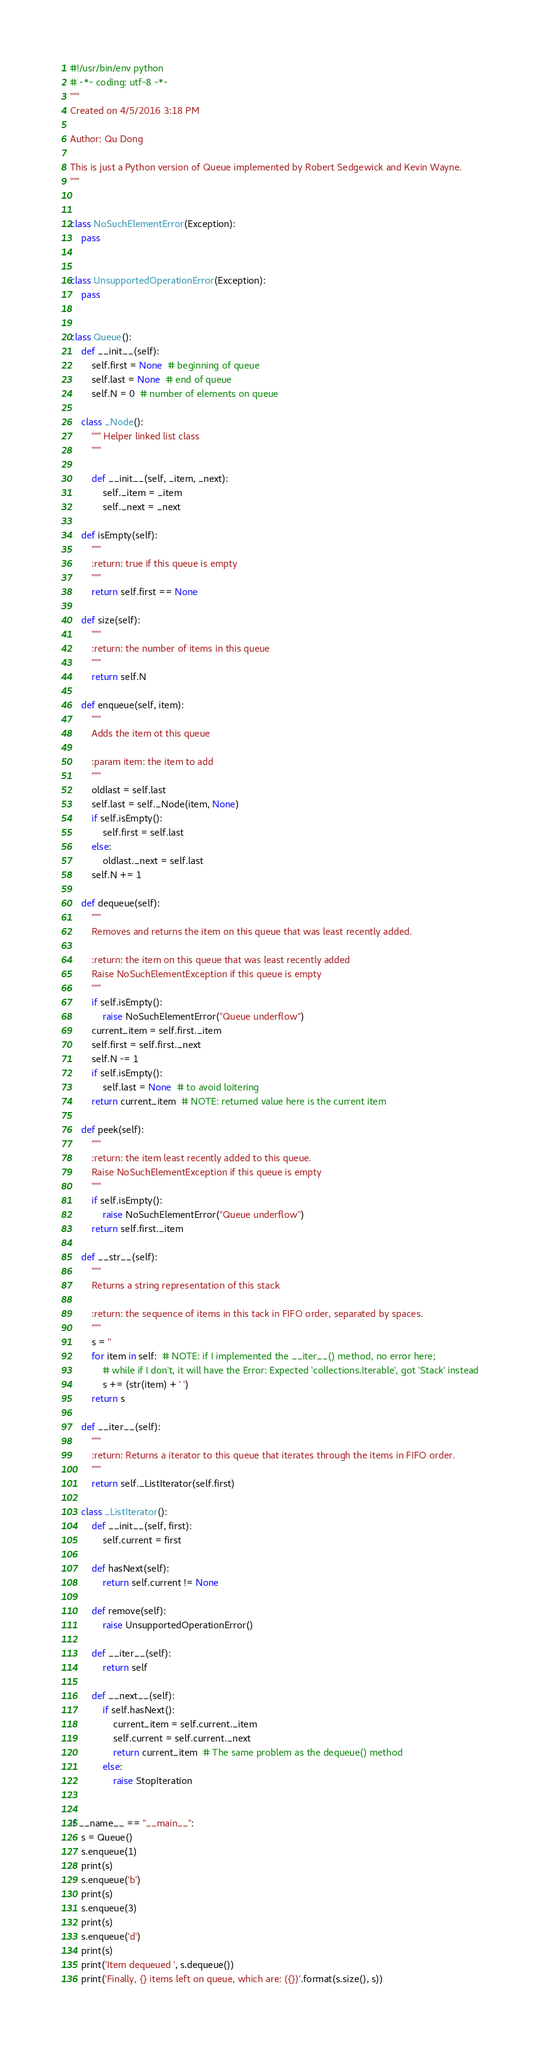Convert code to text. <code><loc_0><loc_0><loc_500><loc_500><_Python_>#!/usr/bin/env python
# -*- coding: utf-8 -*-
"""
Created on 4/5/2016 3:18 PM

Author: Qu Dong

This is just a Python version of Queue implemented by Robert Sedgewick and Kevin Wayne.
"""


class NoSuchElementError(Exception):
    pass


class UnsupportedOperationError(Exception):
    pass


class Queue():
    def __init__(self):
        self.first = None  # beginning of queue
        self.last = None  # end of queue
        self.N = 0  # number of elements on queue

    class _Node():
        """ Helper linked list class
        """

        def __init__(self, _item, _next):
            self._item = _item
            self._next = _next

    def isEmpty(self):
        """
        :return: true if this queue is empty
        """
        return self.first == None

    def size(self):
        """
        :return: the number of items in this queue
        """
        return self.N

    def enqueue(self, item):
        """
        Adds the item ot this queue

        :param item: the item to add
        """
        oldlast = self.last
        self.last = self._Node(item, None)
        if self.isEmpty():
            self.first = self.last
        else:
            oldlast._next = self.last
        self.N += 1

    def dequeue(self):
        """
        Removes and returns the item on this queue that was least recently added.

        :return: the item on this queue that was least recently added
        Raise NoSuchElementException if this queue is empty
        """
        if self.isEmpty():
            raise NoSuchElementError("Queue underflow")
        current_item = self.first._item
        self.first = self.first._next
        self.N -= 1
        if self.isEmpty():
            self.last = None  # to avoid loitering
        return current_item  # NOTE: returned value here is the current item

    def peek(self):
        """
        :return: the item least recently added to this queue.
        Raise NoSuchElementException if this queue is empty
        """
        if self.isEmpty():
            raise NoSuchElementError("Queue underflow")
        return self.first._item

    def __str__(self):
        """
        Returns a string representation of this stack

        :return: the sequence of items in this tack in FIFO order, separated by spaces.
        """
        s = ''
        for item in self:  # NOTE: if I implemented the __iter__() method, no error here;
            # while if I don't, it will have the Error: Expected 'collections.Iterable', got 'Stack' instead
            s += (str(item) + ' ')
        return s

    def __iter__(self):
        """
        :return: Returns a iterator to this queue that iterates through the items in FIFO order.
        """
        return self._ListIterator(self.first)

    class _ListIterator():
        def __init__(self, first):
            self.current = first

        def hasNext(self):
            return self.current != None

        def remove(self):
            raise UnsupportedOperationError()

        def __iter__(self):
            return self

        def __next__(self):
            if self.hasNext():
                current_item = self.current._item
                self.current = self.current._next
                return current_item  # The same problem as the dequeue() method
            else:
                raise StopIteration


if __name__ == "__main__":
    s = Queue()
    s.enqueue(1)
    print(s)
    s.enqueue('b')
    print(s)
    s.enqueue(3)
    print(s)
    s.enqueue('d')
    print(s)
    print('Item dequeued ', s.dequeue())
    print('Finally, {} items left on queue, which are: ({})'.format(s.size(), s))</code> 